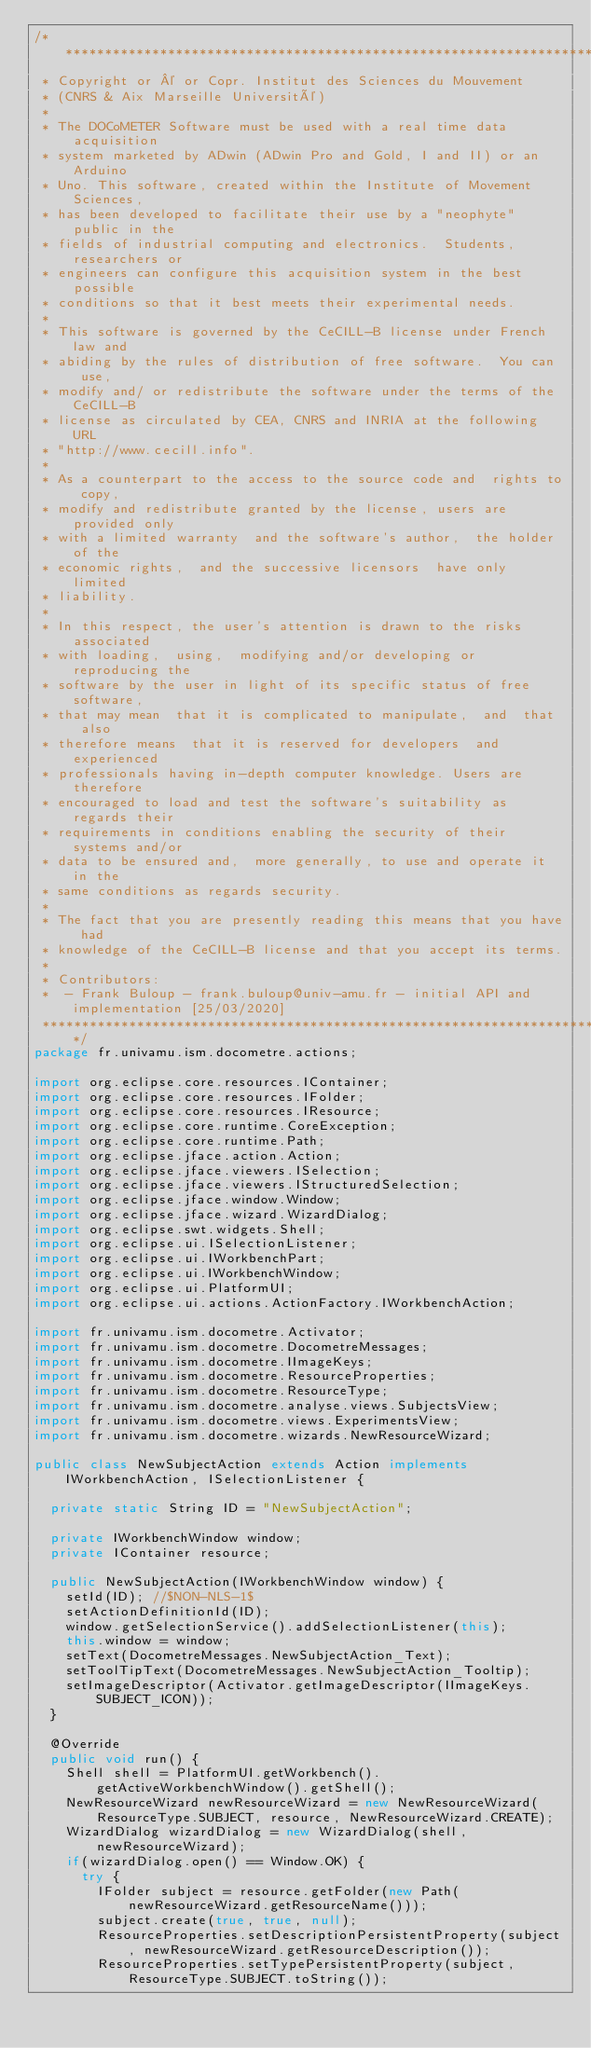Convert code to text. <code><loc_0><loc_0><loc_500><loc_500><_Java_>/*******************************************************************************
 * Copyright or © or Copr. Institut des Sciences du Mouvement 
 * (CNRS & Aix Marseille Université)
 * 
 * The DOCoMETER Software must be used with a real time data acquisition 
 * system marketed by ADwin (ADwin Pro and Gold, I and II) or an Arduino 
 * Uno. This software, created within the Institute of Movement Sciences, 
 * has been developed to facilitate their use by a "neophyte" public in the 
 * fields of industrial computing and electronics.  Students, researchers or 
 * engineers can configure this acquisition system in the best possible 
 * conditions so that it best meets their experimental needs. 
 * 
 * This software is governed by the CeCILL-B license under French law and
 * abiding by the rules of distribution of free software.  You can  use, 
 * modify and/ or redistribute the software under the terms of the CeCILL-B
 * license as circulated by CEA, CNRS and INRIA at the following URL
 * "http://www.cecill.info". 
 * 
 * As a counterpart to the access to the source code and  rights to copy,
 * modify and redistribute granted by the license, users are provided only
 * with a limited warranty  and the software's author,  the holder of the
 * economic rights,  and the successive licensors  have only  limited
 * liability. 
 * 
 * In this respect, the user's attention is drawn to the risks associated
 * with loading,  using,  modifying and/or developing or reproducing the
 * software by the user in light of its specific status of free software,
 * that may mean  that it is complicated to manipulate,  and  that  also
 * therefore means  that it is reserved for developers  and  experienced
 * professionals having in-depth computer knowledge. Users are therefore
 * encouraged to load and test the software's suitability as regards their
 * requirements in conditions enabling the security of their systems and/or 
 * data to be ensured and,  more generally, to use and operate it in the 
 * same conditions as regards security. 
 * 
 * The fact that you are presently reading this means that you have had
 * knowledge of the CeCILL-B license and that you accept its terms.
 * 
 * Contributors:
 *  - Frank Buloup - frank.buloup@univ-amu.fr - initial API and implementation [25/03/2020]
 ******************************************************************************/
package fr.univamu.ism.docometre.actions;

import org.eclipse.core.resources.IContainer;
import org.eclipse.core.resources.IFolder;
import org.eclipse.core.resources.IResource;
import org.eclipse.core.runtime.CoreException;
import org.eclipse.core.runtime.Path;
import org.eclipse.jface.action.Action;
import org.eclipse.jface.viewers.ISelection;
import org.eclipse.jface.viewers.IStructuredSelection;
import org.eclipse.jface.window.Window;
import org.eclipse.jface.wizard.WizardDialog;
import org.eclipse.swt.widgets.Shell;
import org.eclipse.ui.ISelectionListener;
import org.eclipse.ui.IWorkbenchPart;
import org.eclipse.ui.IWorkbenchWindow;
import org.eclipse.ui.PlatformUI;
import org.eclipse.ui.actions.ActionFactory.IWorkbenchAction;

import fr.univamu.ism.docometre.Activator;
import fr.univamu.ism.docometre.DocometreMessages;
import fr.univamu.ism.docometre.IImageKeys;
import fr.univamu.ism.docometre.ResourceProperties;
import fr.univamu.ism.docometre.ResourceType;
import fr.univamu.ism.docometre.analyse.views.SubjectsView;
import fr.univamu.ism.docometre.views.ExperimentsView;
import fr.univamu.ism.docometre.wizards.NewResourceWizard;

public class NewSubjectAction extends Action implements IWorkbenchAction, ISelectionListener {
	
	private static String ID = "NewSubjectAction";

	private IWorkbenchWindow window;
	private IContainer resource;

	public NewSubjectAction(IWorkbenchWindow window) {
		setId(ID); //$NON-NLS-1$
		setActionDefinitionId(ID);
		window.getSelectionService().addSelectionListener(this);
		this.window = window;
		setText(DocometreMessages.NewSubjectAction_Text);
		setToolTipText(DocometreMessages.NewSubjectAction_Tooltip);
		setImageDescriptor(Activator.getImageDescriptor(IImageKeys.SUBJECT_ICON));
	}
	
	@Override
	public void run() {
		Shell shell = PlatformUI.getWorkbench().getActiveWorkbenchWindow().getShell();
		NewResourceWizard newResourceWizard = new NewResourceWizard(ResourceType.SUBJECT, resource, NewResourceWizard.CREATE);
		WizardDialog wizardDialog = new WizardDialog(shell, newResourceWizard);
		if(wizardDialog.open() == Window.OK) {
			try {
				IFolder subject = resource.getFolder(new Path(newResourceWizard.getResourceName()));
				subject.create(true, true, null);
				ResourceProperties.setDescriptionPersistentProperty(subject, newResourceWizard.getResourceDescription());
				ResourceProperties.setTypePersistentProperty(subject, ResourceType.SUBJECT.toString());</code> 